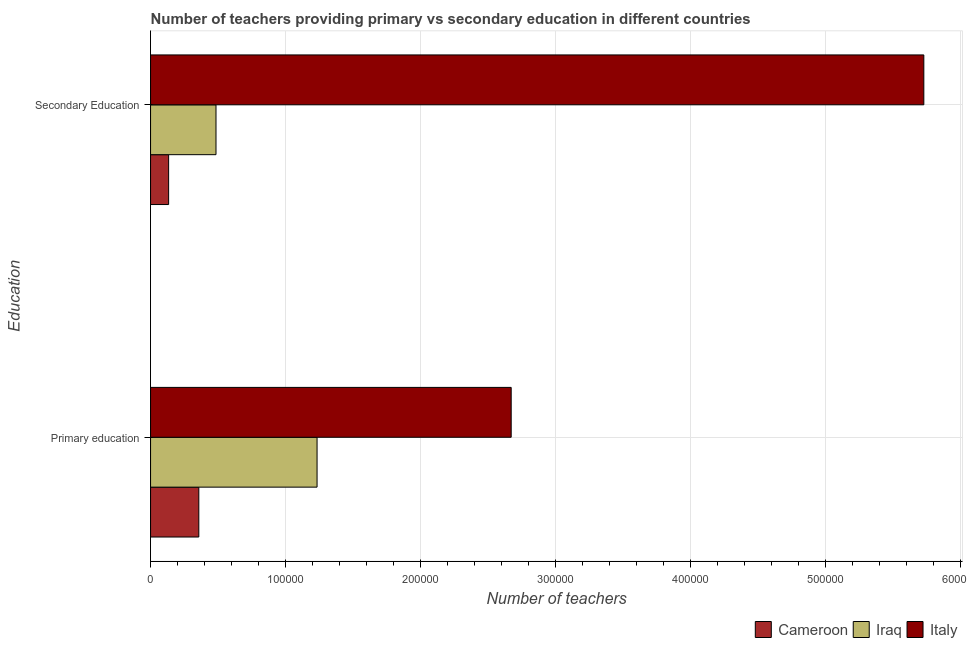How many different coloured bars are there?
Offer a very short reply. 3. How many groups of bars are there?
Your response must be concise. 2. Are the number of bars per tick equal to the number of legend labels?
Offer a terse response. Yes. How many bars are there on the 2nd tick from the top?
Offer a terse response. 3. What is the label of the 1st group of bars from the top?
Offer a very short reply. Secondary Education. What is the number of secondary teachers in Iraq?
Your response must be concise. 4.85e+04. Across all countries, what is the maximum number of primary teachers?
Offer a terse response. 2.67e+05. Across all countries, what is the minimum number of secondary teachers?
Give a very brief answer. 1.34e+04. In which country was the number of primary teachers minimum?
Ensure brevity in your answer.  Cameroon. What is the total number of primary teachers in the graph?
Provide a short and direct response. 4.26e+05. What is the difference between the number of primary teachers in Italy and that in Iraq?
Your response must be concise. 1.44e+05. What is the difference between the number of primary teachers in Iraq and the number of secondary teachers in Italy?
Provide a succinct answer. -4.49e+05. What is the average number of secondary teachers per country?
Make the answer very short. 2.11e+05. What is the difference between the number of primary teachers and number of secondary teachers in Iraq?
Give a very brief answer. 7.49e+04. What is the ratio of the number of secondary teachers in Italy to that in Iraq?
Ensure brevity in your answer.  11.82. Is the number of secondary teachers in Cameroon less than that in Iraq?
Offer a terse response. Yes. In how many countries, is the number of secondary teachers greater than the average number of secondary teachers taken over all countries?
Ensure brevity in your answer.  1. What does the 2nd bar from the top in Secondary Education represents?
Your response must be concise. Iraq. What does the 1st bar from the bottom in Primary education represents?
Your answer should be compact. Cameroon. How many bars are there?
Offer a terse response. 6. How many countries are there in the graph?
Provide a short and direct response. 3. What is the difference between two consecutive major ticks on the X-axis?
Ensure brevity in your answer.  1.00e+05. Does the graph contain grids?
Keep it short and to the point. Yes. How are the legend labels stacked?
Provide a short and direct response. Horizontal. What is the title of the graph?
Your answer should be compact. Number of teachers providing primary vs secondary education in different countries. Does "Sub-Saharan Africa (all income levels)" appear as one of the legend labels in the graph?
Keep it short and to the point. No. What is the label or title of the X-axis?
Ensure brevity in your answer.  Number of teachers. What is the label or title of the Y-axis?
Your answer should be compact. Education. What is the Number of teachers of Cameroon in Primary education?
Your response must be concise. 3.57e+04. What is the Number of teachers in Iraq in Primary education?
Offer a very short reply. 1.23e+05. What is the Number of teachers of Italy in Primary education?
Provide a succinct answer. 2.67e+05. What is the Number of teachers in Cameroon in Secondary Education?
Ensure brevity in your answer.  1.34e+04. What is the Number of teachers in Iraq in Secondary Education?
Provide a short and direct response. 4.85e+04. What is the Number of teachers in Italy in Secondary Education?
Your answer should be very brief. 5.73e+05. Across all Education, what is the maximum Number of teachers in Cameroon?
Your answer should be compact. 3.57e+04. Across all Education, what is the maximum Number of teachers of Iraq?
Provide a succinct answer. 1.23e+05. Across all Education, what is the maximum Number of teachers of Italy?
Provide a short and direct response. 5.73e+05. Across all Education, what is the minimum Number of teachers in Cameroon?
Provide a succinct answer. 1.34e+04. Across all Education, what is the minimum Number of teachers in Iraq?
Provide a short and direct response. 4.85e+04. Across all Education, what is the minimum Number of teachers in Italy?
Offer a very short reply. 2.67e+05. What is the total Number of teachers of Cameroon in the graph?
Your response must be concise. 4.91e+04. What is the total Number of teachers of Iraq in the graph?
Ensure brevity in your answer.  1.72e+05. What is the total Number of teachers in Italy in the graph?
Give a very brief answer. 8.40e+05. What is the difference between the Number of teachers of Cameroon in Primary education and that in Secondary Education?
Offer a terse response. 2.24e+04. What is the difference between the Number of teachers of Iraq in Primary education and that in Secondary Education?
Ensure brevity in your answer.  7.49e+04. What is the difference between the Number of teachers of Italy in Primary education and that in Secondary Education?
Provide a short and direct response. -3.06e+05. What is the difference between the Number of teachers in Cameroon in Primary education and the Number of teachers in Iraq in Secondary Education?
Ensure brevity in your answer.  -1.27e+04. What is the difference between the Number of teachers in Cameroon in Primary education and the Number of teachers in Italy in Secondary Education?
Provide a succinct answer. -5.37e+05. What is the difference between the Number of teachers of Iraq in Primary education and the Number of teachers of Italy in Secondary Education?
Make the answer very short. -4.49e+05. What is the average Number of teachers in Cameroon per Education?
Your response must be concise. 2.45e+04. What is the average Number of teachers in Iraq per Education?
Give a very brief answer. 8.59e+04. What is the average Number of teachers of Italy per Education?
Offer a very short reply. 4.20e+05. What is the difference between the Number of teachers in Cameroon and Number of teachers in Iraq in Primary education?
Ensure brevity in your answer.  -8.76e+04. What is the difference between the Number of teachers in Cameroon and Number of teachers in Italy in Primary education?
Your answer should be very brief. -2.31e+05. What is the difference between the Number of teachers of Iraq and Number of teachers of Italy in Primary education?
Your answer should be very brief. -1.44e+05. What is the difference between the Number of teachers in Cameroon and Number of teachers in Iraq in Secondary Education?
Offer a very short reply. -3.51e+04. What is the difference between the Number of teachers in Cameroon and Number of teachers in Italy in Secondary Education?
Your answer should be very brief. -5.59e+05. What is the difference between the Number of teachers of Iraq and Number of teachers of Italy in Secondary Education?
Offer a very short reply. -5.24e+05. What is the ratio of the Number of teachers of Cameroon in Primary education to that in Secondary Education?
Ensure brevity in your answer.  2.67. What is the ratio of the Number of teachers in Iraq in Primary education to that in Secondary Education?
Ensure brevity in your answer.  2.54. What is the ratio of the Number of teachers of Italy in Primary education to that in Secondary Education?
Keep it short and to the point. 0.47. What is the difference between the highest and the second highest Number of teachers in Cameroon?
Keep it short and to the point. 2.24e+04. What is the difference between the highest and the second highest Number of teachers in Iraq?
Your response must be concise. 7.49e+04. What is the difference between the highest and the second highest Number of teachers of Italy?
Your response must be concise. 3.06e+05. What is the difference between the highest and the lowest Number of teachers of Cameroon?
Give a very brief answer. 2.24e+04. What is the difference between the highest and the lowest Number of teachers in Iraq?
Make the answer very short. 7.49e+04. What is the difference between the highest and the lowest Number of teachers in Italy?
Make the answer very short. 3.06e+05. 